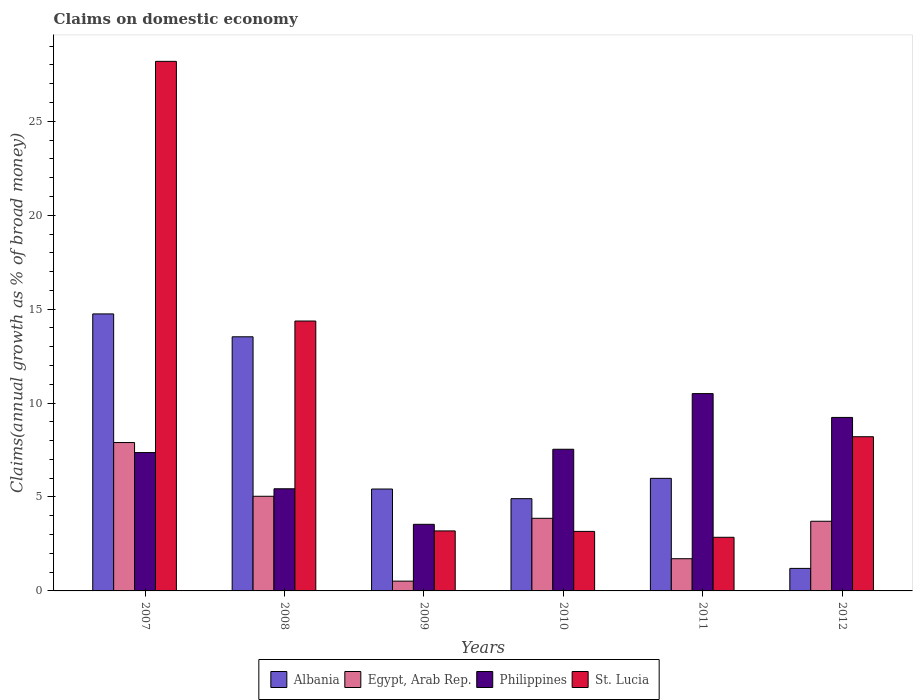How many groups of bars are there?
Your response must be concise. 6. Are the number of bars on each tick of the X-axis equal?
Provide a short and direct response. Yes. In how many cases, is the number of bars for a given year not equal to the number of legend labels?
Provide a short and direct response. 0. What is the percentage of broad money claimed on domestic economy in Albania in 2011?
Provide a succinct answer. 5.99. Across all years, what is the maximum percentage of broad money claimed on domestic economy in Albania?
Provide a short and direct response. 14.75. Across all years, what is the minimum percentage of broad money claimed on domestic economy in Albania?
Provide a succinct answer. 1.2. What is the total percentage of broad money claimed on domestic economy in Egypt, Arab Rep. in the graph?
Your response must be concise. 22.75. What is the difference between the percentage of broad money claimed on domestic economy in Albania in 2007 and that in 2011?
Your response must be concise. 8.75. What is the difference between the percentage of broad money claimed on domestic economy in Egypt, Arab Rep. in 2011 and the percentage of broad money claimed on domestic economy in St. Lucia in 2012?
Your response must be concise. -6.49. What is the average percentage of broad money claimed on domestic economy in St. Lucia per year?
Your response must be concise. 10. In the year 2011, what is the difference between the percentage of broad money claimed on domestic economy in Egypt, Arab Rep. and percentage of broad money claimed on domestic economy in Philippines?
Provide a succinct answer. -8.79. In how many years, is the percentage of broad money claimed on domestic economy in Albania greater than 23 %?
Give a very brief answer. 0. What is the ratio of the percentage of broad money claimed on domestic economy in Albania in 2008 to that in 2012?
Provide a short and direct response. 11.28. Is the difference between the percentage of broad money claimed on domestic economy in Egypt, Arab Rep. in 2011 and 2012 greater than the difference between the percentage of broad money claimed on domestic economy in Philippines in 2011 and 2012?
Make the answer very short. No. What is the difference between the highest and the second highest percentage of broad money claimed on domestic economy in St. Lucia?
Provide a short and direct response. 13.82. What is the difference between the highest and the lowest percentage of broad money claimed on domestic economy in St. Lucia?
Keep it short and to the point. 25.34. In how many years, is the percentage of broad money claimed on domestic economy in Albania greater than the average percentage of broad money claimed on domestic economy in Albania taken over all years?
Provide a succinct answer. 2. Is it the case that in every year, the sum of the percentage of broad money claimed on domestic economy in Albania and percentage of broad money claimed on domestic economy in St. Lucia is greater than the sum of percentage of broad money claimed on domestic economy in Philippines and percentage of broad money claimed on domestic economy in Egypt, Arab Rep.?
Your response must be concise. No. What does the 2nd bar from the left in 2008 represents?
Give a very brief answer. Egypt, Arab Rep. What does the 1st bar from the right in 2012 represents?
Your answer should be compact. St. Lucia. Are all the bars in the graph horizontal?
Your answer should be very brief. No. Does the graph contain any zero values?
Offer a very short reply. No. Where does the legend appear in the graph?
Provide a short and direct response. Bottom center. How many legend labels are there?
Provide a short and direct response. 4. What is the title of the graph?
Your answer should be compact. Claims on domestic economy. Does "Guatemala" appear as one of the legend labels in the graph?
Your answer should be compact. No. What is the label or title of the X-axis?
Offer a very short reply. Years. What is the label or title of the Y-axis?
Make the answer very short. Claims(annual growth as % of broad money). What is the Claims(annual growth as % of broad money) of Albania in 2007?
Your answer should be very brief. 14.75. What is the Claims(annual growth as % of broad money) of Egypt, Arab Rep. in 2007?
Your answer should be compact. 7.9. What is the Claims(annual growth as % of broad money) in Philippines in 2007?
Offer a terse response. 7.37. What is the Claims(annual growth as % of broad money) in St. Lucia in 2007?
Offer a terse response. 28.19. What is the Claims(annual growth as % of broad money) in Albania in 2008?
Your response must be concise. 13.53. What is the Claims(annual growth as % of broad money) in Egypt, Arab Rep. in 2008?
Provide a short and direct response. 5.04. What is the Claims(annual growth as % of broad money) in Philippines in 2008?
Ensure brevity in your answer.  5.44. What is the Claims(annual growth as % of broad money) of St. Lucia in 2008?
Provide a short and direct response. 14.37. What is the Claims(annual growth as % of broad money) of Albania in 2009?
Keep it short and to the point. 5.42. What is the Claims(annual growth as % of broad money) of Egypt, Arab Rep. in 2009?
Keep it short and to the point. 0.52. What is the Claims(annual growth as % of broad money) in Philippines in 2009?
Give a very brief answer. 3.55. What is the Claims(annual growth as % of broad money) in St. Lucia in 2009?
Ensure brevity in your answer.  3.19. What is the Claims(annual growth as % of broad money) of Albania in 2010?
Offer a very short reply. 4.91. What is the Claims(annual growth as % of broad money) in Egypt, Arab Rep. in 2010?
Give a very brief answer. 3.87. What is the Claims(annual growth as % of broad money) of Philippines in 2010?
Ensure brevity in your answer.  7.54. What is the Claims(annual growth as % of broad money) of St. Lucia in 2010?
Offer a very short reply. 3.17. What is the Claims(annual growth as % of broad money) in Albania in 2011?
Your answer should be very brief. 5.99. What is the Claims(annual growth as % of broad money) of Egypt, Arab Rep. in 2011?
Provide a succinct answer. 1.71. What is the Claims(annual growth as % of broad money) of Philippines in 2011?
Make the answer very short. 10.5. What is the Claims(annual growth as % of broad money) of St. Lucia in 2011?
Make the answer very short. 2.86. What is the Claims(annual growth as % of broad money) in Albania in 2012?
Your response must be concise. 1.2. What is the Claims(annual growth as % of broad money) of Egypt, Arab Rep. in 2012?
Provide a succinct answer. 3.71. What is the Claims(annual growth as % of broad money) of Philippines in 2012?
Your answer should be compact. 9.24. What is the Claims(annual growth as % of broad money) in St. Lucia in 2012?
Give a very brief answer. 8.21. Across all years, what is the maximum Claims(annual growth as % of broad money) of Albania?
Your answer should be very brief. 14.75. Across all years, what is the maximum Claims(annual growth as % of broad money) in Egypt, Arab Rep.?
Give a very brief answer. 7.9. Across all years, what is the maximum Claims(annual growth as % of broad money) in Philippines?
Provide a succinct answer. 10.5. Across all years, what is the maximum Claims(annual growth as % of broad money) in St. Lucia?
Your answer should be compact. 28.19. Across all years, what is the minimum Claims(annual growth as % of broad money) in Albania?
Give a very brief answer. 1.2. Across all years, what is the minimum Claims(annual growth as % of broad money) in Egypt, Arab Rep.?
Your answer should be very brief. 0.52. Across all years, what is the minimum Claims(annual growth as % of broad money) of Philippines?
Ensure brevity in your answer.  3.55. Across all years, what is the minimum Claims(annual growth as % of broad money) of St. Lucia?
Give a very brief answer. 2.86. What is the total Claims(annual growth as % of broad money) in Albania in the graph?
Provide a short and direct response. 45.8. What is the total Claims(annual growth as % of broad money) in Egypt, Arab Rep. in the graph?
Your answer should be compact. 22.75. What is the total Claims(annual growth as % of broad money) in Philippines in the graph?
Your response must be concise. 43.63. What is the total Claims(annual growth as % of broad money) of St. Lucia in the graph?
Your response must be concise. 59.99. What is the difference between the Claims(annual growth as % of broad money) of Albania in 2007 and that in 2008?
Provide a short and direct response. 1.22. What is the difference between the Claims(annual growth as % of broad money) of Egypt, Arab Rep. in 2007 and that in 2008?
Provide a short and direct response. 2.86. What is the difference between the Claims(annual growth as % of broad money) in Philippines in 2007 and that in 2008?
Your response must be concise. 1.93. What is the difference between the Claims(annual growth as % of broad money) of St. Lucia in 2007 and that in 2008?
Provide a succinct answer. 13.82. What is the difference between the Claims(annual growth as % of broad money) of Albania in 2007 and that in 2009?
Ensure brevity in your answer.  9.32. What is the difference between the Claims(annual growth as % of broad money) of Egypt, Arab Rep. in 2007 and that in 2009?
Provide a succinct answer. 7.38. What is the difference between the Claims(annual growth as % of broad money) of Philippines in 2007 and that in 2009?
Your answer should be compact. 3.82. What is the difference between the Claims(annual growth as % of broad money) of St. Lucia in 2007 and that in 2009?
Make the answer very short. 25. What is the difference between the Claims(annual growth as % of broad money) in Albania in 2007 and that in 2010?
Provide a succinct answer. 9.84. What is the difference between the Claims(annual growth as % of broad money) in Egypt, Arab Rep. in 2007 and that in 2010?
Provide a short and direct response. 4.03. What is the difference between the Claims(annual growth as % of broad money) of Philippines in 2007 and that in 2010?
Your answer should be very brief. -0.18. What is the difference between the Claims(annual growth as % of broad money) of St. Lucia in 2007 and that in 2010?
Your answer should be compact. 25.02. What is the difference between the Claims(annual growth as % of broad money) of Albania in 2007 and that in 2011?
Provide a succinct answer. 8.75. What is the difference between the Claims(annual growth as % of broad money) in Egypt, Arab Rep. in 2007 and that in 2011?
Your answer should be very brief. 6.18. What is the difference between the Claims(annual growth as % of broad money) of Philippines in 2007 and that in 2011?
Provide a short and direct response. -3.14. What is the difference between the Claims(annual growth as % of broad money) in St. Lucia in 2007 and that in 2011?
Provide a short and direct response. 25.34. What is the difference between the Claims(annual growth as % of broad money) of Albania in 2007 and that in 2012?
Your answer should be compact. 13.55. What is the difference between the Claims(annual growth as % of broad money) in Egypt, Arab Rep. in 2007 and that in 2012?
Give a very brief answer. 4.19. What is the difference between the Claims(annual growth as % of broad money) in Philippines in 2007 and that in 2012?
Keep it short and to the point. -1.87. What is the difference between the Claims(annual growth as % of broad money) in St. Lucia in 2007 and that in 2012?
Your response must be concise. 19.98. What is the difference between the Claims(annual growth as % of broad money) of Albania in 2008 and that in 2009?
Your answer should be very brief. 8.1. What is the difference between the Claims(annual growth as % of broad money) in Egypt, Arab Rep. in 2008 and that in 2009?
Provide a short and direct response. 4.52. What is the difference between the Claims(annual growth as % of broad money) of Philippines in 2008 and that in 2009?
Provide a succinct answer. 1.89. What is the difference between the Claims(annual growth as % of broad money) of St. Lucia in 2008 and that in 2009?
Offer a very short reply. 11.17. What is the difference between the Claims(annual growth as % of broad money) in Albania in 2008 and that in 2010?
Offer a terse response. 8.62. What is the difference between the Claims(annual growth as % of broad money) in Egypt, Arab Rep. in 2008 and that in 2010?
Provide a succinct answer. 1.17. What is the difference between the Claims(annual growth as % of broad money) in Philippines in 2008 and that in 2010?
Your response must be concise. -2.1. What is the difference between the Claims(annual growth as % of broad money) in St. Lucia in 2008 and that in 2010?
Your answer should be compact. 11.2. What is the difference between the Claims(annual growth as % of broad money) of Albania in 2008 and that in 2011?
Your answer should be very brief. 7.54. What is the difference between the Claims(annual growth as % of broad money) of Egypt, Arab Rep. in 2008 and that in 2011?
Your answer should be compact. 3.32. What is the difference between the Claims(annual growth as % of broad money) in Philippines in 2008 and that in 2011?
Ensure brevity in your answer.  -5.07. What is the difference between the Claims(annual growth as % of broad money) of St. Lucia in 2008 and that in 2011?
Your response must be concise. 11.51. What is the difference between the Claims(annual growth as % of broad money) of Albania in 2008 and that in 2012?
Your response must be concise. 12.33. What is the difference between the Claims(annual growth as % of broad money) of Egypt, Arab Rep. in 2008 and that in 2012?
Your response must be concise. 1.33. What is the difference between the Claims(annual growth as % of broad money) of Philippines in 2008 and that in 2012?
Provide a succinct answer. -3.8. What is the difference between the Claims(annual growth as % of broad money) of St. Lucia in 2008 and that in 2012?
Provide a short and direct response. 6.16. What is the difference between the Claims(annual growth as % of broad money) in Albania in 2009 and that in 2010?
Ensure brevity in your answer.  0.51. What is the difference between the Claims(annual growth as % of broad money) in Egypt, Arab Rep. in 2009 and that in 2010?
Your response must be concise. -3.34. What is the difference between the Claims(annual growth as % of broad money) in Philippines in 2009 and that in 2010?
Your response must be concise. -4. What is the difference between the Claims(annual growth as % of broad money) in St. Lucia in 2009 and that in 2010?
Make the answer very short. 0.03. What is the difference between the Claims(annual growth as % of broad money) of Albania in 2009 and that in 2011?
Ensure brevity in your answer.  -0.57. What is the difference between the Claims(annual growth as % of broad money) of Egypt, Arab Rep. in 2009 and that in 2011?
Provide a short and direct response. -1.19. What is the difference between the Claims(annual growth as % of broad money) of Philippines in 2009 and that in 2011?
Provide a short and direct response. -6.96. What is the difference between the Claims(annual growth as % of broad money) in St. Lucia in 2009 and that in 2011?
Your response must be concise. 0.34. What is the difference between the Claims(annual growth as % of broad money) of Albania in 2009 and that in 2012?
Make the answer very short. 4.23. What is the difference between the Claims(annual growth as % of broad money) in Egypt, Arab Rep. in 2009 and that in 2012?
Give a very brief answer. -3.19. What is the difference between the Claims(annual growth as % of broad money) of Philippines in 2009 and that in 2012?
Your response must be concise. -5.69. What is the difference between the Claims(annual growth as % of broad money) in St. Lucia in 2009 and that in 2012?
Offer a terse response. -5.01. What is the difference between the Claims(annual growth as % of broad money) in Albania in 2010 and that in 2011?
Provide a short and direct response. -1.08. What is the difference between the Claims(annual growth as % of broad money) of Egypt, Arab Rep. in 2010 and that in 2011?
Offer a very short reply. 2.15. What is the difference between the Claims(annual growth as % of broad money) of Philippines in 2010 and that in 2011?
Give a very brief answer. -2.96. What is the difference between the Claims(annual growth as % of broad money) of St. Lucia in 2010 and that in 2011?
Your response must be concise. 0.31. What is the difference between the Claims(annual growth as % of broad money) of Albania in 2010 and that in 2012?
Ensure brevity in your answer.  3.71. What is the difference between the Claims(annual growth as % of broad money) of Egypt, Arab Rep. in 2010 and that in 2012?
Provide a short and direct response. 0.16. What is the difference between the Claims(annual growth as % of broad money) in Philippines in 2010 and that in 2012?
Offer a terse response. -1.69. What is the difference between the Claims(annual growth as % of broad money) of St. Lucia in 2010 and that in 2012?
Your answer should be compact. -5.04. What is the difference between the Claims(annual growth as % of broad money) in Albania in 2011 and that in 2012?
Your answer should be compact. 4.79. What is the difference between the Claims(annual growth as % of broad money) of Egypt, Arab Rep. in 2011 and that in 2012?
Give a very brief answer. -1.99. What is the difference between the Claims(annual growth as % of broad money) of Philippines in 2011 and that in 2012?
Keep it short and to the point. 1.27. What is the difference between the Claims(annual growth as % of broad money) in St. Lucia in 2011 and that in 2012?
Keep it short and to the point. -5.35. What is the difference between the Claims(annual growth as % of broad money) in Albania in 2007 and the Claims(annual growth as % of broad money) in Egypt, Arab Rep. in 2008?
Make the answer very short. 9.71. What is the difference between the Claims(annual growth as % of broad money) in Albania in 2007 and the Claims(annual growth as % of broad money) in Philippines in 2008?
Offer a very short reply. 9.31. What is the difference between the Claims(annual growth as % of broad money) in Albania in 2007 and the Claims(annual growth as % of broad money) in St. Lucia in 2008?
Ensure brevity in your answer.  0.38. What is the difference between the Claims(annual growth as % of broad money) of Egypt, Arab Rep. in 2007 and the Claims(annual growth as % of broad money) of Philippines in 2008?
Ensure brevity in your answer.  2.46. What is the difference between the Claims(annual growth as % of broad money) in Egypt, Arab Rep. in 2007 and the Claims(annual growth as % of broad money) in St. Lucia in 2008?
Provide a short and direct response. -6.47. What is the difference between the Claims(annual growth as % of broad money) of Philippines in 2007 and the Claims(annual growth as % of broad money) of St. Lucia in 2008?
Make the answer very short. -7. What is the difference between the Claims(annual growth as % of broad money) in Albania in 2007 and the Claims(annual growth as % of broad money) in Egypt, Arab Rep. in 2009?
Your response must be concise. 14.23. What is the difference between the Claims(annual growth as % of broad money) of Albania in 2007 and the Claims(annual growth as % of broad money) of Philippines in 2009?
Make the answer very short. 11.2. What is the difference between the Claims(annual growth as % of broad money) of Albania in 2007 and the Claims(annual growth as % of broad money) of St. Lucia in 2009?
Keep it short and to the point. 11.55. What is the difference between the Claims(annual growth as % of broad money) of Egypt, Arab Rep. in 2007 and the Claims(annual growth as % of broad money) of Philippines in 2009?
Keep it short and to the point. 4.35. What is the difference between the Claims(annual growth as % of broad money) in Egypt, Arab Rep. in 2007 and the Claims(annual growth as % of broad money) in St. Lucia in 2009?
Provide a succinct answer. 4.7. What is the difference between the Claims(annual growth as % of broad money) of Philippines in 2007 and the Claims(annual growth as % of broad money) of St. Lucia in 2009?
Your answer should be compact. 4.17. What is the difference between the Claims(annual growth as % of broad money) in Albania in 2007 and the Claims(annual growth as % of broad money) in Egypt, Arab Rep. in 2010?
Keep it short and to the point. 10.88. What is the difference between the Claims(annual growth as % of broad money) of Albania in 2007 and the Claims(annual growth as % of broad money) of Philippines in 2010?
Ensure brevity in your answer.  7.2. What is the difference between the Claims(annual growth as % of broad money) in Albania in 2007 and the Claims(annual growth as % of broad money) in St. Lucia in 2010?
Your answer should be very brief. 11.58. What is the difference between the Claims(annual growth as % of broad money) in Egypt, Arab Rep. in 2007 and the Claims(annual growth as % of broad money) in Philippines in 2010?
Offer a very short reply. 0.36. What is the difference between the Claims(annual growth as % of broad money) in Egypt, Arab Rep. in 2007 and the Claims(annual growth as % of broad money) in St. Lucia in 2010?
Ensure brevity in your answer.  4.73. What is the difference between the Claims(annual growth as % of broad money) of Philippines in 2007 and the Claims(annual growth as % of broad money) of St. Lucia in 2010?
Provide a succinct answer. 4.2. What is the difference between the Claims(annual growth as % of broad money) of Albania in 2007 and the Claims(annual growth as % of broad money) of Egypt, Arab Rep. in 2011?
Offer a very short reply. 13.03. What is the difference between the Claims(annual growth as % of broad money) of Albania in 2007 and the Claims(annual growth as % of broad money) of Philippines in 2011?
Give a very brief answer. 4.24. What is the difference between the Claims(annual growth as % of broad money) in Albania in 2007 and the Claims(annual growth as % of broad money) in St. Lucia in 2011?
Offer a terse response. 11.89. What is the difference between the Claims(annual growth as % of broad money) of Egypt, Arab Rep. in 2007 and the Claims(annual growth as % of broad money) of Philippines in 2011?
Your answer should be compact. -2.6. What is the difference between the Claims(annual growth as % of broad money) of Egypt, Arab Rep. in 2007 and the Claims(annual growth as % of broad money) of St. Lucia in 2011?
Your answer should be very brief. 5.04. What is the difference between the Claims(annual growth as % of broad money) in Philippines in 2007 and the Claims(annual growth as % of broad money) in St. Lucia in 2011?
Provide a short and direct response. 4.51. What is the difference between the Claims(annual growth as % of broad money) in Albania in 2007 and the Claims(annual growth as % of broad money) in Egypt, Arab Rep. in 2012?
Offer a very short reply. 11.04. What is the difference between the Claims(annual growth as % of broad money) of Albania in 2007 and the Claims(annual growth as % of broad money) of Philippines in 2012?
Provide a short and direct response. 5.51. What is the difference between the Claims(annual growth as % of broad money) of Albania in 2007 and the Claims(annual growth as % of broad money) of St. Lucia in 2012?
Ensure brevity in your answer.  6.54. What is the difference between the Claims(annual growth as % of broad money) in Egypt, Arab Rep. in 2007 and the Claims(annual growth as % of broad money) in Philippines in 2012?
Offer a very short reply. -1.34. What is the difference between the Claims(annual growth as % of broad money) in Egypt, Arab Rep. in 2007 and the Claims(annual growth as % of broad money) in St. Lucia in 2012?
Ensure brevity in your answer.  -0.31. What is the difference between the Claims(annual growth as % of broad money) in Philippines in 2007 and the Claims(annual growth as % of broad money) in St. Lucia in 2012?
Ensure brevity in your answer.  -0.84. What is the difference between the Claims(annual growth as % of broad money) of Albania in 2008 and the Claims(annual growth as % of broad money) of Egypt, Arab Rep. in 2009?
Your response must be concise. 13.01. What is the difference between the Claims(annual growth as % of broad money) in Albania in 2008 and the Claims(annual growth as % of broad money) in Philippines in 2009?
Make the answer very short. 9.98. What is the difference between the Claims(annual growth as % of broad money) of Albania in 2008 and the Claims(annual growth as % of broad money) of St. Lucia in 2009?
Make the answer very short. 10.33. What is the difference between the Claims(annual growth as % of broad money) of Egypt, Arab Rep. in 2008 and the Claims(annual growth as % of broad money) of Philippines in 2009?
Offer a terse response. 1.49. What is the difference between the Claims(annual growth as % of broad money) of Egypt, Arab Rep. in 2008 and the Claims(annual growth as % of broad money) of St. Lucia in 2009?
Offer a very short reply. 1.84. What is the difference between the Claims(annual growth as % of broad money) in Philippines in 2008 and the Claims(annual growth as % of broad money) in St. Lucia in 2009?
Your response must be concise. 2.24. What is the difference between the Claims(annual growth as % of broad money) in Albania in 2008 and the Claims(annual growth as % of broad money) in Egypt, Arab Rep. in 2010?
Offer a terse response. 9.66. What is the difference between the Claims(annual growth as % of broad money) of Albania in 2008 and the Claims(annual growth as % of broad money) of Philippines in 2010?
Ensure brevity in your answer.  5.99. What is the difference between the Claims(annual growth as % of broad money) of Albania in 2008 and the Claims(annual growth as % of broad money) of St. Lucia in 2010?
Give a very brief answer. 10.36. What is the difference between the Claims(annual growth as % of broad money) in Egypt, Arab Rep. in 2008 and the Claims(annual growth as % of broad money) in Philippines in 2010?
Offer a terse response. -2.5. What is the difference between the Claims(annual growth as % of broad money) in Egypt, Arab Rep. in 2008 and the Claims(annual growth as % of broad money) in St. Lucia in 2010?
Your answer should be very brief. 1.87. What is the difference between the Claims(annual growth as % of broad money) in Philippines in 2008 and the Claims(annual growth as % of broad money) in St. Lucia in 2010?
Your answer should be compact. 2.27. What is the difference between the Claims(annual growth as % of broad money) of Albania in 2008 and the Claims(annual growth as % of broad money) of Egypt, Arab Rep. in 2011?
Provide a short and direct response. 11.81. What is the difference between the Claims(annual growth as % of broad money) of Albania in 2008 and the Claims(annual growth as % of broad money) of Philippines in 2011?
Your response must be concise. 3.02. What is the difference between the Claims(annual growth as % of broad money) in Albania in 2008 and the Claims(annual growth as % of broad money) in St. Lucia in 2011?
Make the answer very short. 10.67. What is the difference between the Claims(annual growth as % of broad money) of Egypt, Arab Rep. in 2008 and the Claims(annual growth as % of broad money) of Philippines in 2011?
Provide a succinct answer. -5.47. What is the difference between the Claims(annual growth as % of broad money) in Egypt, Arab Rep. in 2008 and the Claims(annual growth as % of broad money) in St. Lucia in 2011?
Ensure brevity in your answer.  2.18. What is the difference between the Claims(annual growth as % of broad money) in Philippines in 2008 and the Claims(annual growth as % of broad money) in St. Lucia in 2011?
Make the answer very short. 2.58. What is the difference between the Claims(annual growth as % of broad money) in Albania in 2008 and the Claims(annual growth as % of broad money) in Egypt, Arab Rep. in 2012?
Offer a terse response. 9.82. What is the difference between the Claims(annual growth as % of broad money) of Albania in 2008 and the Claims(annual growth as % of broad money) of Philippines in 2012?
Offer a terse response. 4.29. What is the difference between the Claims(annual growth as % of broad money) of Albania in 2008 and the Claims(annual growth as % of broad money) of St. Lucia in 2012?
Your answer should be very brief. 5.32. What is the difference between the Claims(annual growth as % of broad money) in Egypt, Arab Rep. in 2008 and the Claims(annual growth as % of broad money) in Philippines in 2012?
Your response must be concise. -4.2. What is the difference between the Claims(annual growth as % of broad money) in Egypt, Arab Rep. in 2008 and the Claims(annual growth as % of broad money) in St. Lucia in 2012?
Give a very brief answer. -3.17. What is the difference between the Claims(annual growth as % of broad money) of Philippines in 2008 and the Claims(annual growth as % of broad money) of St. Lucia in 2012?
Provide a short and direct response. -2.77. What is the difference between the Claims(annual growth as % of broad money) in Albania in 2009 and the Claims(annual growth as % of broad money) in Egypt, Arab Rep. in 2010?
Your response must be concise. 1.56. What is the difference between the Claims(annual growth as % of broad money) in Albania in 2009 and the Claims(annual growth as % of broad money) in Philippines in 2010?
Your answer should be compact. -2.12. What is the difference between the Claims(annual growth as % of broad money) in Albania in 2009 and the Claims(annual growth as % of broad money) in St. Lucia in 2010?
Your response must be concise. 2.26. What is the difference between the Claims(annual growth as % of broad money) of Egypt, Arab Rep. in 2009 and the Claims(annual growth as % of broad money) of Philippines in 2010?
Your answer should be very brief. -7.02. What is the difference between the Claims(annual growth as % of broad money) of Egypt, Arab Rep. in 2009 and the Claims(annual growth as % of broad money) of St. Lucia in 2010?
Keep it short and to the point. -2.65. What is the difference between the Claims(annual growth as % of broad money) in Philippines in 2009 and the Claims(annual growth as % of broad money) in St. Lucia in 2010?
Offer a terse response. 0.38. What is the difference between the Claims(annual growth as % of broad money) of Albania in 2009 and the Claims(annual growth as % of broad money) of Egypt, Arab Rep. in 2011?
Give a very brief answer. 3.71. What is the difference between the Claims(annual growth as % of broad money) of Albania in 2009 and the Claims(annual growth as % of broad money) of Philippines in 2011?
Make the answer very short. -5.08. What is the difference between the Claims(annual growth as % of broad money) of Albania in 2009 and the Claims(annual growth as % of broad money) of St. Lucia in 2011?
Give a very brief answer. 2.57. What is the difference between the Claims(annual growth as % of broad money) in Egypt, Arab Rep. in 2009 and the Claims(annual growth as % of broad money) in Philippines in 2011?
Your answer should be very brief. -9.98. What is the difference between the Claims(annual growth as % of broad money) of Egypt, Arab Rep. in 2009 and the Claims(annual growth as % of broad money) of St. Lucia in 2011?
Ensure brevity in your answer.  -2.33. What is the difference between the Claims(annual growth as % of broad money) in Philippines in 2009 and the Claims(annual growth as % of broad money) in St. Lucia in 2011?
Provide a succinct answer. 0.69. What is the difference between the Claims(annual growth as % of broad money) in Albania in 2009 and the Claims(annual growth as % of broad money) in Egypt, Arab Rep. in 2012?
Provide a short and direct response. 1.72. What is the difference between the Claims(annual growth as % of broad money) in Albania in 2009 and the Claims(annual growth as % of broad money) in Philippines in 2012?
Make the answer very short. -3.81. What is the difference between the Claims(annual growth as % of broad money) of Albania in 2009 and the Claims(annual growth as % of broad money) of St. Lucia in 2012?
Offer a very short reply. -2.78. What is the difference between the Claims(annual growth as % of broad money) in Egypt, Arab Rep. in 2009 and the Claims(annual growth as % of broad money) in Philippines in 2012?
Your response must be concise. -8.72. What is the difference between the Claims(annual growth as % of broad money) of Egypt, Arab Rep. in 2009 and the Claims(annual growth as % of broad money) of St. Lucia in 2012?
Your answer should be compact. -7.69. What is the difference between the Claims(annual growth as % of broad money) of Philippines in 2009 and the Claims(annual growth as % of broad money) of St. Lucia in 2012?
Provide a succinct answer. -4.66. What is the difference between the Claims(annual growth as % of broad money) in Albania in 2010 and the Claims(annual growth as % of broad money) in Egypt, Arab Rep. in 2011?
Your answer should be compact. 3.2. What is the difference between the Claims(annual growth as % of broad money) of Albania in 2010 and the Claims(annual growth as % of broad money) of Philippines in 2011?
Keep it short and to the point. -5.59. What is the difference between the Claims(annual growth as % of broad money) of Albania in 2010 and the Claims(annual growth as % of broad money) of St. Lucia in 2011?
Provide a short and direct response. 2.06. What is the difference between the Claims(annual growth as % of broad money) in Egypt, Arab Rep. in 2010 and the Claims(annual growth as % of broad money) in Philippines in 2011?
Offer a very short reply. -6.64. What is the difference between the Claims(annual growth as % of broad money) of Egypt, Arab Rep. in 2010 and the Claims(annual growth as % of broad money) of St. Lucia in 2011?
Ensure brevity in your answer.  1.01. What is the difference between the Claims(annual growth as % of broad money) of Philippines in 2010 and the Claims(annual growth as % of broad money) of St. Lucia in 2011?
Offer a terse response. 4.69. What is the difference between the Claims(annual growth as % of broad money) of Albania in 2010 and the Claims(annual growth as % of broad money) of Egypt, Arab Rep. in 2012?
Your answer should be very brief. 1.2. What is the difference between the Claims(annual growth as % of broad money) of Albania in 2010 and the Claims(annual growth as % of broad money) of Philippines in 2012?
Give a very brief answer. -4.33. What is the difference between the Claims(annual growth as % of broad money) in Albania in 2010 and the Claims(annual growth as % of broad money) in St. Lucia in 2012?
Your answer should be very brief. -3.3. What is the difference between the Claims(annual growth as % of broad money) in Egypt, Arab Rep. in 2010 and the Claims(annual growth as % of broad money) in Philippines in 2012?
Ensure brevity in your answer.  -5.37. What is the difference between the Claims(annual growth as % of broad money) of Egypt, Arab Rep. in 2010 and the Claims(annual growth as % of broad money) of St. Lucia in 2012?
Your answer should be compact. -4.34. What is the difference between the Claims(annual growth as % of broad money) in Philippines in 2010 and the Claims(annual growth as % of broad money) in St. Lucia in 2012?
Provide a short and direct response. -0.67. What is the difference between the Claims(annual growth as % of broad money) of Albania in 2011 and the Claims(annual growth as % of broad money) of Egypt, Arab Rep. in 2012?
Keep it short and to the point. 2.28. What is the difference between the Claims(annual growth as % of broad money) of Albania in 2011 and the Claims(annual growth as % of broad money) of Philippines in 2012?
Your answer should be compact. -3.24. What is the difference between the Claims(annual growth as % of broad money) of Albania in 2011 and the Claims(annual growth as % of broad money) of St. Lucia in 2012?
Offer a terse response. -2.22. What is the difference between the Claims(annual growth as % of broad money) of Egypt, Arab Rep. in 2011 and the Claims(annual growth as % of broad money) of Philippines in 2012?
Ensure brevity in your answer.  -7.52. What is the difference between the Claims(annual growth as % of broad money) of Egypt, Arab Rep. in 2011 and the Claims(annual growth as % of broad money) of St. Lucia in 2012?
Offer a very short reply. -6.49. What is the difference between the Claims(annual growth as % of broad money) in Philippines in 2011 and the Claims(annual growth as % of broad money) in St. Lucia in 2012?
Offer a terse response. 2.3. What is the average Claims(annual growth as % of broad money) of Albania per year?
Keep it short and to the point. 7.63. What is the average Claims(annual growth as % of broad money) of Egypt, Arab Rep. per year?
Give a very brief answer. 3.79. What is the average Claims(annual growth as % of broad money) in Philippines per year?
Offer a terse response. 7.27. What is the average Claims(annual growth as % of broad money) in St. Lucia per year?
Your answer should be compact. 10. In the year 2007, what is the difference between the Claims(annual growth as % of broad money) of Albania and Claims(annual growth as % of broad money) of Egypt, Arab Rep.?
Make the answer very short. 6.85. In the year 2007, what is the difference between the Claims(annual growth as % of broad money) in Albania and Claims(annual growth as % of broad money) in Philippines?
Provide a short and direct response. 7.38. In the year 2007, what is the difference between the Claims(annual growth as % of broad money) of Albania and Claims(annual growth as % of broad money) of St. Lucia?
Provide a succinct answer. -13.45. In the year 2007, what is the difference between the Claims(annual growth as % of broad money) in Egypt, Arab Rep. and Claims(annual growth as % of broad money) in Philippines?
Give a very brief answer. 0.53. In the year 2007, what is the difference between the Claims(annual growth as % of broad money) of Egypt, Arab Rep. and Claims(annual growth as % of broad money) of St. Lucia?
Your response must be concise. -20.29. In the year 2007, what is the difference between the Claims(annual growth as % of broad money) in Philippines and Claims(annual growth as % of broad money) in St. Lucia?
Ensure brevity in your answer.  -20.83. In the year 2008, what is the difference between the Claims(annual growth as % of broad money) of Albania and Claims(annual growth as % of broad money) of Egypt, Arab Rep.?
Provide a succinct answer. 8.49. In the year 2008, what is the difference between the Claims(annual growth as % of broad money) in Albania and Claims(annual growth as % of broad money) in Philippines?
Offer a terse response. 8.09. In the year 2008, what is the difference between the Claims(annual growth as % of broad money) in Albania and Claims(annual growth as % of broad money) in St. Lucia?
Your answer should be very brief. -0.84. In the year 2008, what is the difference between the Claims(annual growth as % of broad money) of Egypt, Arab Rep. and Claims(annual growth as % of broad money) of Philippines?
Keep it short and to the point. -0.4. In the year 2008, what is the difference between the Claims(annual growth as % of broad money) of Egypt, Arab Rep. and Claims(annual growth as % of broad money) of St. Lucia?
Offer a very short reply. -9.33. In the year 2008, what is the difference between the Claims(annual growth as % of broad money) in Philippines and Claims(annual growth as % of broad money) in St. Lucia?
Your response must be concise. -8.93. In the year 2009, what is the difference between the Claims(annual growth as % of broad money) of Albania and Claims(annual growth as % of broad money) of Egypt, Arab Rep.?
Make the answer very short. 4.9. In the year 2009, what is the difference between the Claims(annual growth as % of broad money) in Albania and Claims(annual growth as % of broad money) in Philippines?
Keep it short and to the point. 1.88. In the year 2009, what is the difference between the Claims(annual growth as % of broad money) of Albania and Claims(annual growth as % of broad money) of St. Lucia?
Your response must be concise. 2.23. In the year 2009, what is the difference between the Claims(annual growth as % of broad money) in Egypt, Arab Rep. and Claims(annual growth as % of broad money) in Philippines?
Your answer should be compact. -3.02. In the year 2009, what is the difference between the Claims(annual growth as % of broad money) of Egypt, Arab Rep. and Claims(annual growth as % of broad money) of St. Lucia?
Offer a very short reply. -2.67. In the year 2009, what is the difference between the Claims(annual growth as % of broad money) of Philippines and Claims(annual growth as % of broad money) of St. Lucia?
Keep it short and to the point. 0.35. In the year 2010, what is the difference between the Claims(annual growth as % of broad money) in Albania and Claims(annual growth as % of broad money) in Egypt, Arab Rep.?
Give a very brief answer. 1.05. In the year 2010, what is the difference between the Claims(annual growth as % of broad money) of Albania and Claims(annual growth as % of broad money) of Philippines?
Provide a succinct answer. -2.63. In the year 2010, what is the difference between the Claims(annual growth as % of broad money) of Albania and Claims(annual growth as % of broad money) of St. Lucia?
Your answer should be compact. 1.74. In the year 2010, what is the difference between the Claims(annual growth as % of broad money) of Egypt, Arab Rep. and Claims(annual growth as % of broad money) of Philippines?
Ensure brevity in your answer.  -3.68. In the year 2010, what is the difference between the Claims(annual growth as % of broad money) in Egypt, Arab Rep. and Claims(annual growth as % of broad money) in St. Lucia?
Your response must be concise. 0.7. In the year 2010, what is the difference between the Claims(annual growth as % of broad money) in Philippines and Claims(annual growth as % of broad money) in St. Lucia?
Keep it short and to the point. 4.37. In the year 2011, what is the difference between the Claims(annual growth as % of broad money) in Albania and Claims(annual growth as % of broad money) in Egypt, Arab Rep.?
Ensure brevity in your answer.  4.28. In the year 2011, what is the difference between the Claims(annual growth as % of broad money) of Albania and Claims(annual growth as % of broad money) of Philippines?
Give a very brief answer. -4.51. In the year 2011, what is the difference between the Claims(annual growth as % of broad money) of Albania and Claims(annual growth as % of broad money) of St. Lucia?
Provide a short and direct response. 3.14. In the year 2011, what is the difference between the Claims(annual growth as % of broad money) of Egypt, Arab Rep. and Claims(annual growth as % of broad money) of Philippines?
Provide a short and direct response. -8.79. In the year 2011, what is the difference between the Claims(annual growth as % of broad money) in Egypt, Arab Rep. and Claims(annual growth as % of broad money) in St. Lucia?
Ensure brevity in your answer.  -1.14. In the year 2011, what is the difference between the Claims(annual growth as % of broad money) of Philippines and Claims(annual growth as % of broad money) of St. Lucia?
Provide a short and direct response. 7.65. In the year 2012, what is the difference between the Claims(annual growth as % of broad money) in Albania and Claims(annual growth as % of broad money) in Egypt, Arab Rep.?
Provide a short and direct response. -2.51. In the year 2012, what is the difference between the Claims(annual growth as % of broad money) in Albania and Claims(annual growth as % of broad money) in Philippines?
Your answer should be very brief. -8.04. In the year 2012, what is the difference between the Claims(annual growth as % of broad money) in Albania and Claims(annual growth as % of broad money) in St. Lucia?
Make the answer very short. -7.01. In the year 2012, what is the difference between the Claims(annual growth as % of broad money) in Egypt, Arab Rep. and Claims(annual growth as % of broad money) in Philippines?
Ensure brevity in your answer.  -5.53. In the year 2012, what is the difference between the Claims(annual growth as % of broad money) in Egypt, Arab Rep. and Claims(annual growth as % of broad money) in St. Lucia?
Provide a succinct answer. -4.5. In the year 2012, what is the difference between the Claims(annual growth as % of broad money) in Philippines and Claims(annual growth as % of broad money) in St. Lucia?
Give a very brief answer. 1.03. What is the ratio of the Claims(annual growth as % of broad money) in Albania in 2007 to that in 2008?
Offer a very short reply. 1.09. What is the ratio of the Claims(annual growth as % of broad money) of Egypt, Arab Rep. in 2007 to that in 2008?
Your answer should be compact. 1.57. What is the ratio of the Claims(annual growth as % of broad money) in Philippines in 2007 to that in 2008?
Provide a succinct answer. 1.35. What is the ratio of the Claims(annual growth as % of broad money) of St. Lucia in 2007 to that in 2008?
Make the answer very short. 1.96. What is the ratio of the Claims(annual growth as % of broad money) of Albania in 2007 to that in 2009?
Offer a terse response. 2.72. What is the ratio of the Claims(annual growth as % of broad money) of Egypt, Arab Rep. in 2007 to that in 2009?
Provide a short and direct response. 15.17. What is the ratio of the Claims(annual growth as % of broad money) of Philippines in 2007 to that in 2009?
Ensure brevity in your answer.  2.08. What is the ratio of the Claims(annual growth as % of broad money) in St. Lucia in 2007 to that in 2009?
Ensure brevity in your answer.  8.83. What is the ratio of the Claims(annual growth as % of broad money) in Albania in 2007 to that in 2010?
Offer a very short reply. 3. What is the ratio of the Claims(annual growth as % of broad money) of Egypt, Arab Rep. in 2007 to that in 2010?
Provide a succinct answer. 2.04. What is the ratio of the Claims(annual growth as % of broad money) in Philippines in 2007 to that in 2010?
Your answer should be compact. 0.98. What is the ratio of the Claims(annual growth as % of broad money) of St. Lucia in 2007 to that in 2010?
Offer a very short reply. 8.9. What is the ratio of the Claims(annual growth as % of broad money) in Albania in 2007 to that in 2011?
Ensure brevity in your answer.  2.46. What is the ratio of the Claims(annual growth as % of broad money) in Egypt, Arab Rep. in 2007 to that in 2011?
Your answer should be compact. 4.61. What is the ratio of the Claims(annual growth as % of broad money) of Philippines in 2007 to that in 2011?
Your answer should be compact. 0.7. What is the ratio of the Claims(annual growth as % of broad money) in St. Lucia in 2007 to that in 2011?
Your answer should be very brief. 9.87. What is the ratio of the Claims(annual growth as % of broad money) in Albania in 2007 to that in 2012?
Ensure brevity in your answer.  12.3. What is the ratio of the Claims(annual growth as % of broad money) in Egypt, Arab Rep. in 2007 to that in 2012?
Provide a short and direct response. 2.13. What is the ratio of the Claims(annual growth as % of broad money) in Philippines in 2007 to that in 2012?
Ensure brevity in your answer.  0.8. What is the ratio of the Claims(annual growth as % of broad money) in St. Lucia in 2007 to that in 2012?
Offer a very short reply. 3.43. What is the ratio of the Claims(annual growth as % of broad money) in Albania in 2008 to that in 2009?
Your answer should be very brief. 2.49. What is the ratio of the Claims(annual growth as % of broad money) in Egypt, Arab Rep. in 2008 to that in 2009?
Your answer should be compact. 9.68. What is the ratio of the Claims(annual growth as % of broad money) in Philippines in 2008 to that in 2009?
Your answer should be compact. 1.53. What is the ratio of the Claims(annual growth as % of broad money) in St. Lucia in 2008 to that in 2009?
Provide a short and direct response. 4.5. What is the ratio of the Claims(annual growth as % of broad money) of Albania in 2008 to that in 2010?
Provide a succinct answer. 2.75. What is the ratio of the Claims(annual growth as % of broad money) in Egypt, Arab Rep. in 2008 to that in 2010?
Provide a short and direct response. 1.3. What is the ratio of the Claims(annual growth as % of broad money) in Philippines in 2008 to that in 2010?
Keep it short and to the point. 0.72. What is the ratio of the Claims(annual growth as % of broad money) of St. Lucia in 2008 to that in 2010?
Offer a terse response. 4.53. What is the ratio of the Claims(annual growth as % of broad money) of Albania in 2008 to that in 2011?
Your answer should be very brief. 2.26. What is the ratio of the Claims(annual growth as % of broad money) in Egypt, Arab Rep. in 2008 to that in 2011?
Your answer should be compact. 2.94. What is the ratio of the Claims(annual growth as % of broad money) in Philippines in 2008 to that in 2011?
Provide a succinct answer. 0.52. What is the ratio of the Claims(annual growth as % of broad money) in St. Lucia in 2008 to that in 2011?
Keep it short and to the point. 5.03. What is the ratio of the Claims(annual growth as % of broad money) in Albania in 2008 to that in 2012?
Keep it short and to the point. 11.28. What is the ratio of the Claims(annual growth as % of broad money) in Egypt, Arab Rep. in 2008 to that in 2012?
Your answer should be compact. 1.36. What is the ratio of the Claims(annual growth as % of broad money) of Philippines in 2008 to that in 2012?
Your response must be concise. 0.59. What is the ratio of the Claims(annual growth as % of broad money) of St. Lucia in 2008 to that in 2012?
Your answer should be very brief. 1.75. What is the ratio of the Claims(annual growth as % of broad money) of Albania in 2009 to that in 2010?
Your response must be concise. 1.1. What is the ratio of the Claims(annual growth as % of broad money) of Egypt, Arab Rep. in 2009 to that in 2010?
Give a very brief answer. 0.13. What is the ratio of the Claims(annual growth as % of broad money) of Philippines in 2009 to that in 2010?
Your response must be concise. 0.47. What is the ratio of the Claims(annual growth as % of broad money) in Albania in 2009 to that in 2011?
Ensure brevity in your answer.  0.91. What is the ratio of the Claims(annual growth as % of broad money) in Egypt, Arab Rep. in 2009 to that in 2011?
Your answer should be compact. 0.3. What is the ratio of the Claims(annual growth as % of broad money) in Philippines in 2009 to that in 2011?
Offer a terse response. 0.34. What is the ratio of the Claims(annual growth as % of broad money) in St. Lucia in 2009 to that in 2011?
Ensure brevity in your answer.  1.12. What is the ratio of the Claims(annual growth as % of broad money) of Albania in 2009 to that in 2012?
Give a very brief answer. 4.52. What is the ratio of the Claims(annual growth as % of broad money) of Egypt, Arab Rep. in 2009 to that in 2012?
Your answer should be compact. 0.14. What is the ratio of the Claims(annual growth as % of broad money) of Philippines in 2009 to that in 2012?
Your answer should be compact. 0.38. What is the ratio of the Claims(annual growth as % of broad money) of St. Lucia in 2009 to that in 2012?
Keep it short and to the point. 0.39. What is the ratio of the Claims(annual growth as % of broad money) in Albania in 2010 to that in 2011?
Provide a succinct answer. 0.82. What is the ratio of the Claims(annual growth as % of broad money) in Egypt, Arab Rep. in 2010 to that in 2011?
Give a very brief answer. 2.25. What is the ratio of the Claims(annual growth as % of broad money) in Philippines in 2010 to that in 2011?
Offer a terse response. 0.72. What is the ratio of the Claims(annual growth as % of broad money) of St. Lucia in 2010 to that in 2011?
Keep it short and to the point. 1.11. What is the ratio of the Claims(annual growth as % of broad money) of Albania in 2010 to that in 2012?
Your answer should be compact. 4.1. What is the ratio of the Claims(annual growth as % of broad money) of Egypt, Arab Rep. in 2010 to that in 2012?
Offer a terse response. 1.04. What is the ratio of the Claims(annual growth as % of broad money) of Philippines in 2010 to that in 2012?
Your answer should be compact. 0.82. What is the ratio of the Claims(annual growth as % of broad money) in St. Lucia in 2010 to that in 2012?
Give a very brief answer. 0.39. What is the ratio of the Claims(annual growth as % of broad money) in Albania in 2011 to that in 2012?
Offer a very short reply. 5. What is the ratio of the Claims(annual growth as % of broad money) in Egypt, Arab Rep. in 2011 to that in 2012?
Offer a very short reply. 0.46. What is the ratio of the Claims(annual growth as % of broad money) of Philippines in 2011 to that in 2012?
Keep it short and to the point. 1.14. What is the ratio of the Claims(annual growth as % of broad money) in St. Lucia in 2011 to that in 2012?
Your answer should be compact. 0.35. What is the difference between the highest and the second highest Claims(annual growth as % of broad money) in Albania?
Your answer should be compact. 1.22. What is the difference between the highest and the second highest Claims(annual growth as % of broad money) of Egypt, Arab Rep.?
Offer a terse response. 2.86. What is the difference between the highest and the second highest Claims(annual growth as % of broad money) of Philippines?
Your answer should be compact. 1.27. What is the difference between the highest and the second highest Claims(annual growth as % of broad money) of St. Lucia?
Provide a succinct answer. 13.82. What is the difference between the highest and the lowest Claims(annual growth as % of broad money) in Albania?
Provide a succinct answer. 13.55. What is the difference between the highest and the lowest Claims(annual growth as % of broad money) in Egypt, Arab Rep.?
Offer a very short reply. 7.38. What is the difference between the highest and the lowest Claims(annual growth as % of broad money) of Philippines?
Ensure brevity in your answer.  6.96. What is the difference between the highest and the lowest Claims(annual growth as % of broad money) of St. Lucia?
Ensure brevity in your answer.  25.34. 